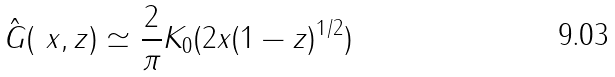<formula> <loc_0><loc_0><loc_500><loc_500>\hat { G } ( \ x , z ) \simeq \frac { 2 } { \pi } K _ { 0 } ( 2 x ( 1 - z ) ^ { 1 / 2 } )</formula> 